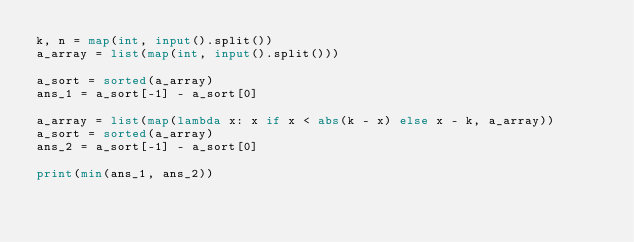Convert code to text. <code><loc_0><loc_0><loc_500><loc_500><_Python_>k, n = map(int, input().split())
a_array = list(map(int, input().split()))

a_sort = sorted(a_array)
ans_1 = a_sort[-1] - a_sort[0]

a_array = list(map(lambda x: x if x < abs(k - x) else x - k, a_array))
a_sort = sorted(a_array)
ans_2 = a_sort[-1] - a_sort[0]

print(min(ans_1, ans_2))</code> 